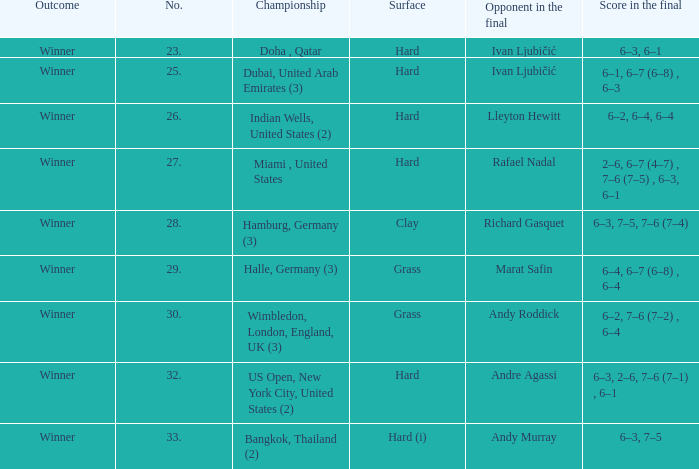How many titles are present on the date january 9, 2005? 1.0. 